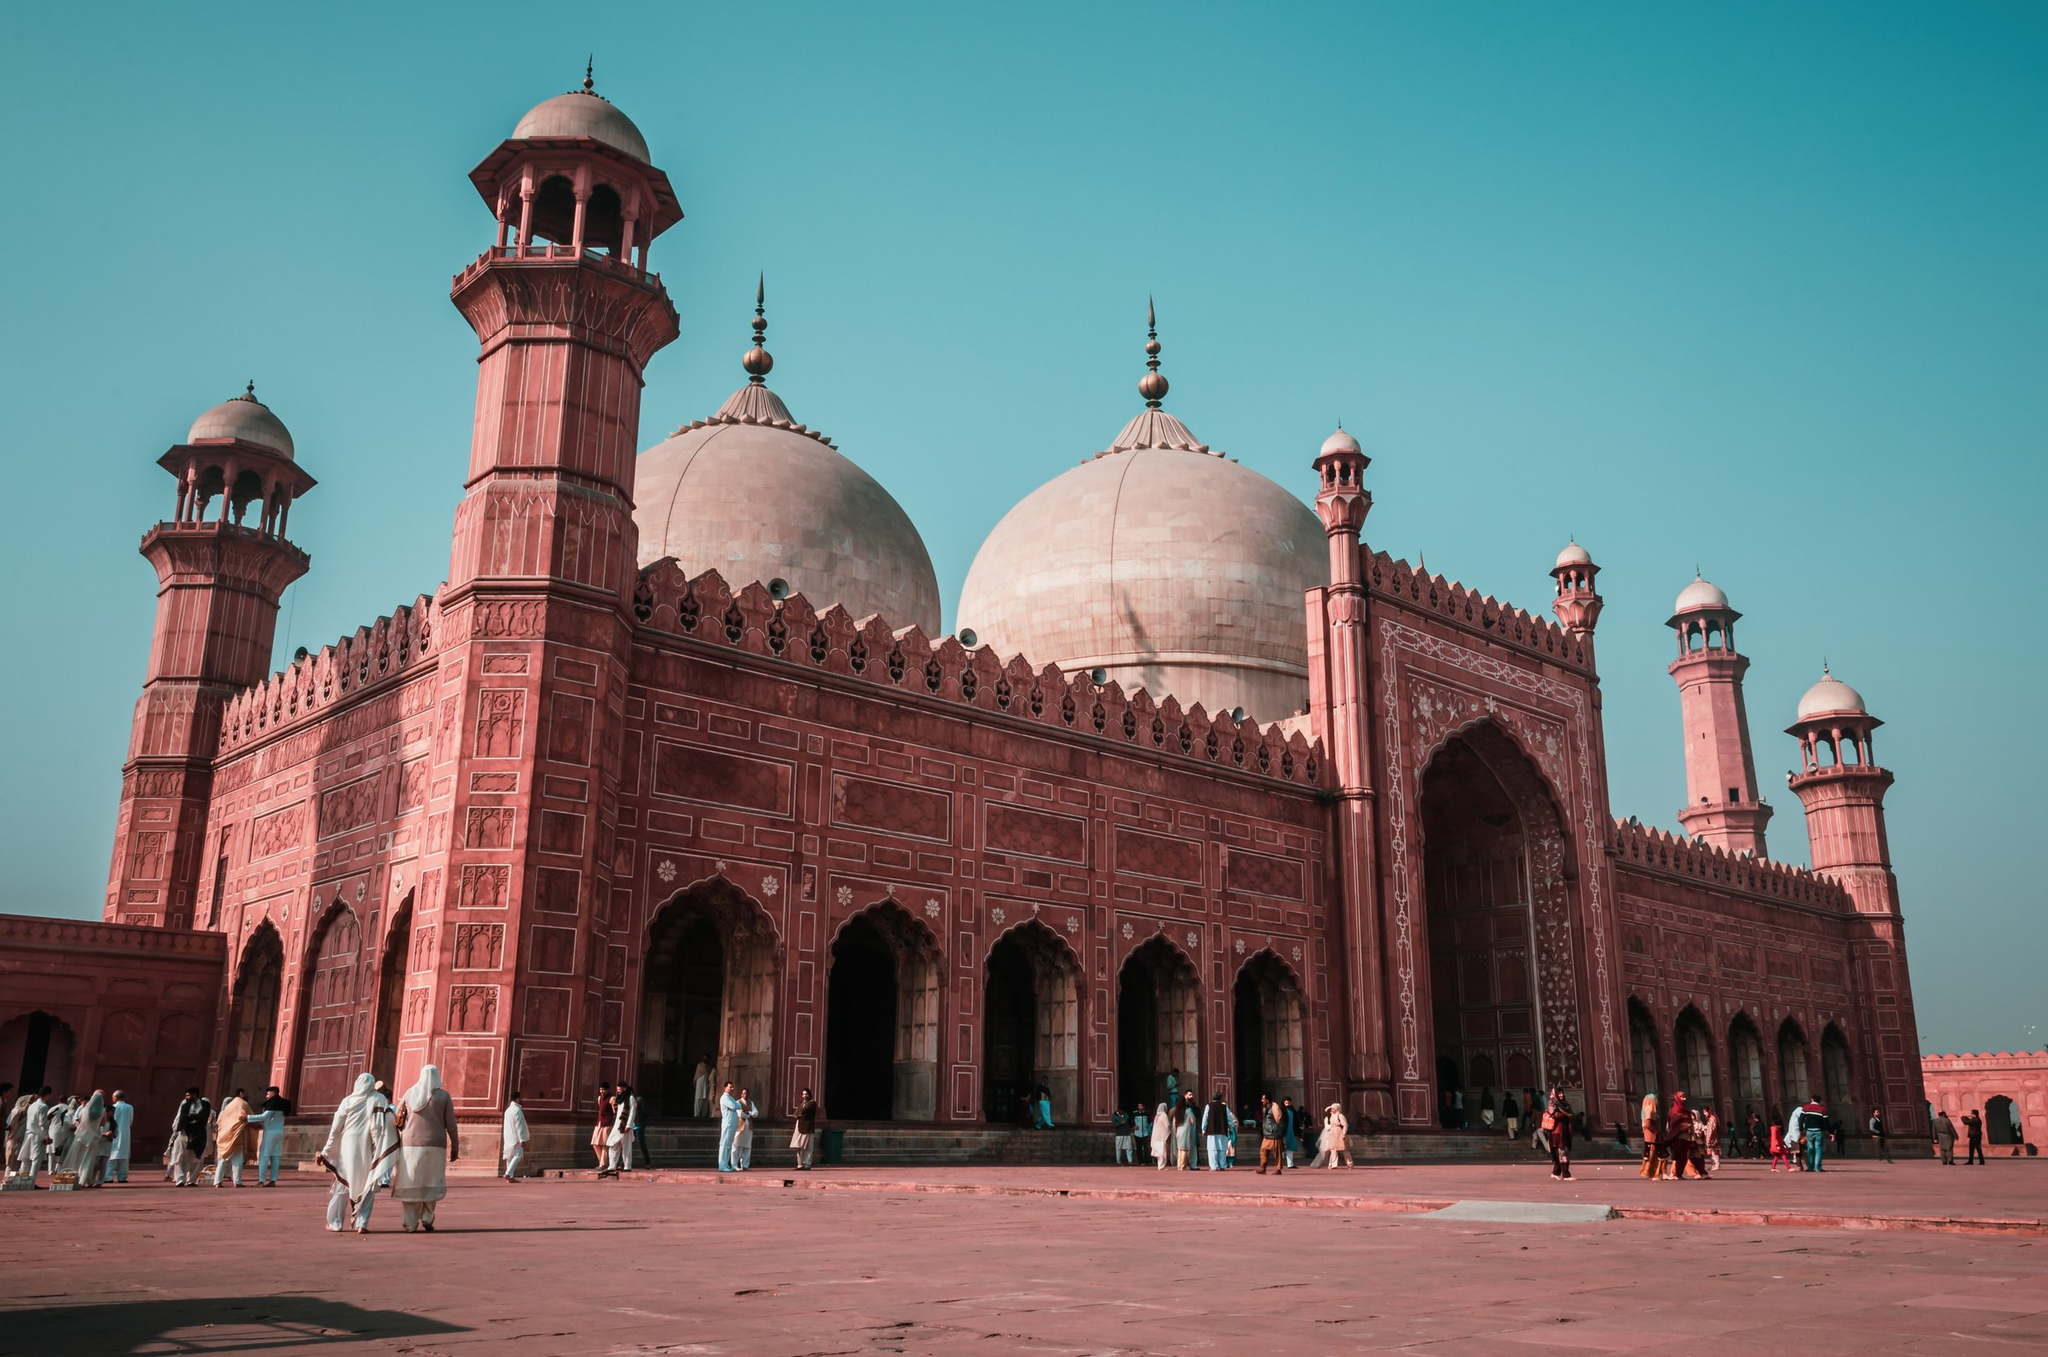Imagine the mosque came to life. How would it recount its history? If the Badshahi Mosque could speak, it would narrate tales of grandeur and resilience. 'I was born in 1673, under the reign of the great Mughal Emperor Aurangzeb. Built to symbolize the might and piety of the empire, I have witnessed centuries pass by, standing tall through wars and upheavals. My walls have echoed the prayers of millions, and my stones have borne the footprints of generations. Every detail in my architecture tells a story – of the artisans who meticulously carved them and of the cultural zeniths they represent. I have seen the rise and fall of empires, and today, I stand as a testament to the timeless blend of faith and craftsmanship. Every visitor who walks through my courtyard adds a new chapter to my enduring saga.' 